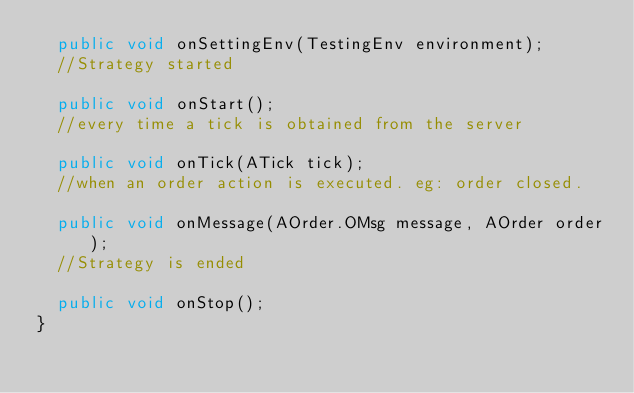Convert code to text. <code><loc_0><loc_0><loc_500><loc_500><_Java_>  public void onSettingEnv(TestingEnv environment);
  //Strategy started

  public void onStart();
  //every time a tick is obtained from the server

  public void onTick(ATick tick);
  //when an order action is executed. eg: order closed.

  public void onMessage(AOrder.OMsg message, AOrder order);
  //Strategy is ended

  public void onStop();
}
</code> 